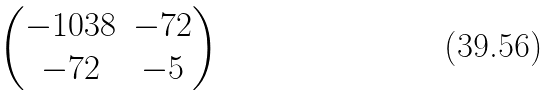Convert formula to latex. <formula><loc_0><loc_0><loc_500><loc_500>\begin{pmatrix} - 1 0 3 8 & - 7 2 \\ - 7 2 & - 5 \end{pmatrix}</formula> 